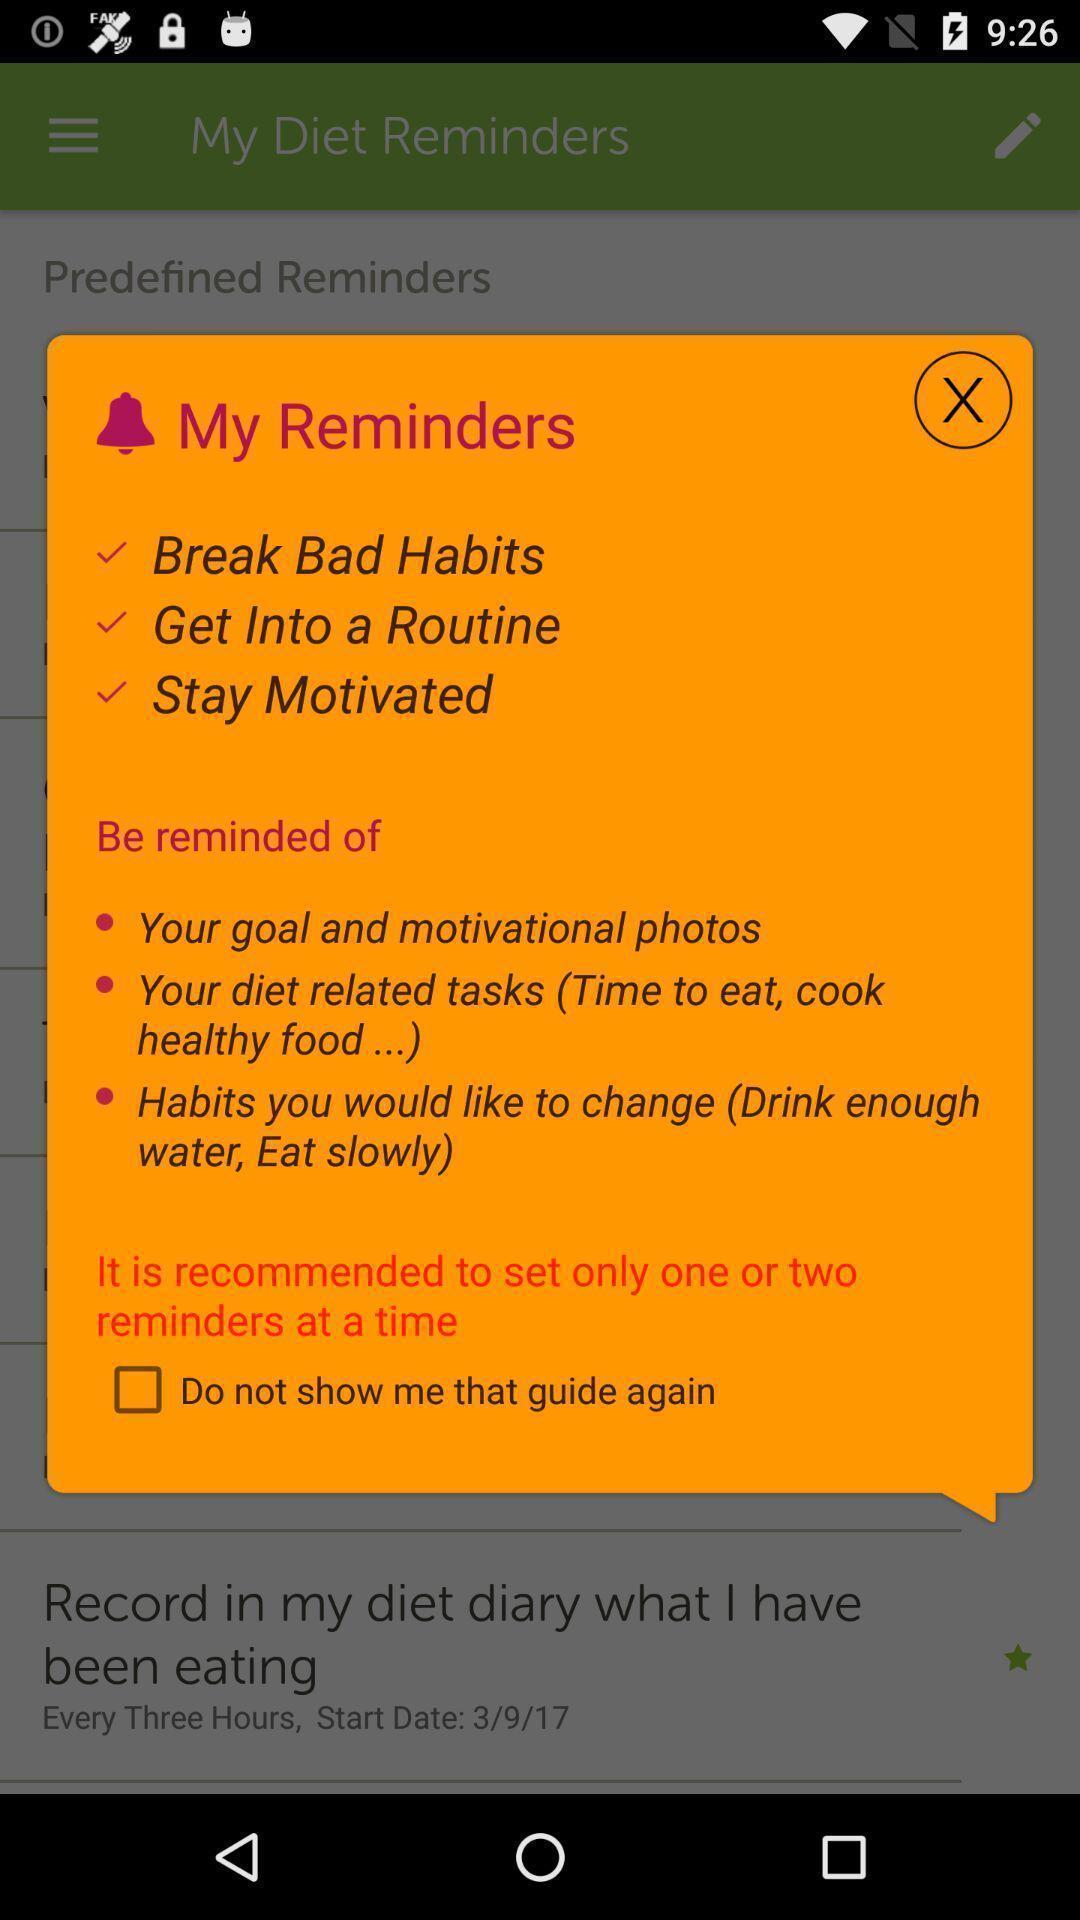Describe the content in this image. Pop-up window showing list of added reminders. 